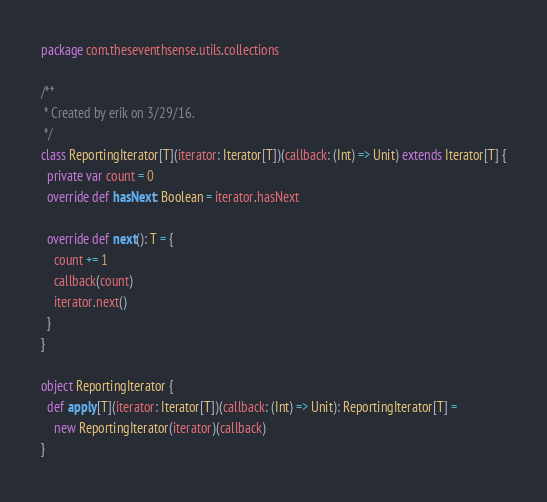<code> <loc_0><loc_0><loc_500><loc_500><_Scala_>package com.theseventhsense.utils.collections

/**
 * Created by erik on 3/29/16.
 */
class ReportingIterator[T](iterator: Iterator[T])(callback: (Int) => Unit) extends Iterator[T] {
  private var count = 0
  override def hasNext: Boolean = iterator.hasNext

  override def next(): T = {
    count += 1
    callback(count)
    iterator.next()
  }
}

object ReportingIterator {
  def apply[T](iterator: Iterator[T])(callback: (Int) => Unit): ReportingIterator[T] =
    new ReportingIterator(iterator)(callback)
}
</code> 